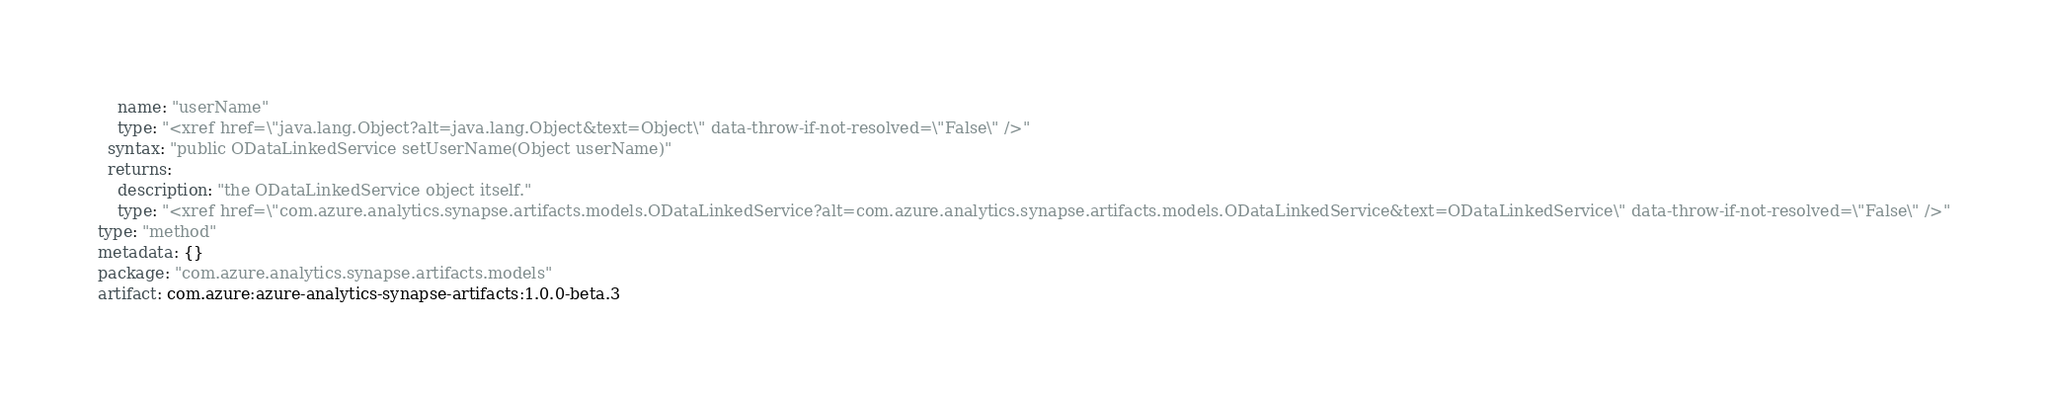<code> <loc_0><loc_0><loc_500><loc_500><_YAML_>    name: "userName"
    type: "<xref href=\"java.lang.Object?alt=java.lang.Object&text=Object\" data-throw-if-not-resolved=\"False\" />"
  syntax: "public ODataLinkedService setUserName(Object userName)"
  returns:
    description: "the ODataLinkedService object itself."
    type: "<xref href=\"com.azure.analytics.synapse.artifacts.models.ODataLinkedService?alt=com.azure.analytics.synapse.artifacts.models.ODataLinkedService&text=ODataLinkedService\" data-throw-if-not-resolved=\"False\" />"
type: "method"
metadata: {}
package: "com.azure.analytics.synapse.artifacts.models"
artifact: com.azure:azure-analytics-synapse-artifacts:1.0.0-beta.3
</code> 